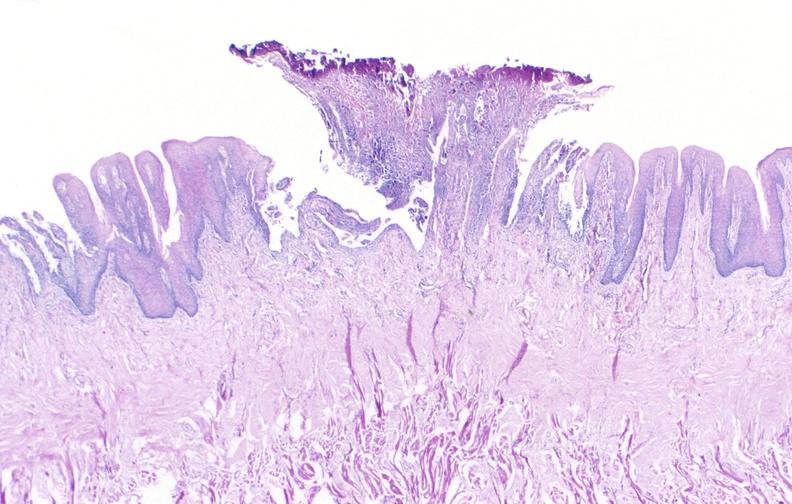what does this image show?
Answer the question using a single word or phrase. Tongue 